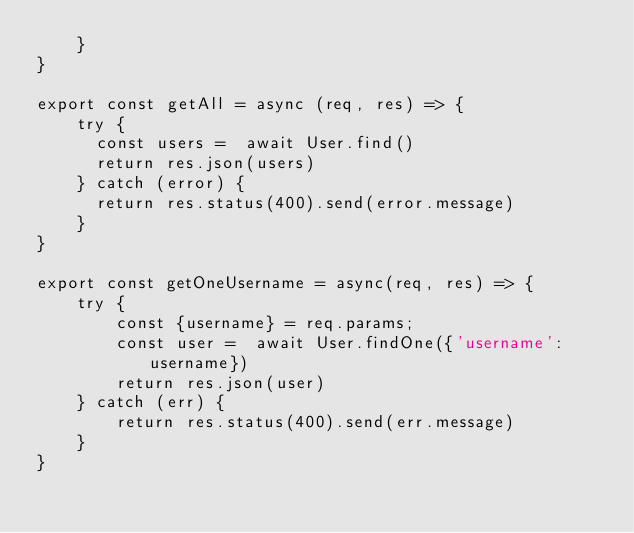<code> <loc_0><loc_0><loc_500><loc_500><_JavaScript_>    }
}

export const getAll = async (req, res) => {
    try {
      const users =  await User.find()
      return res.json(users)
    } catch (error) {
      return res.status(400).send(error.message)
    }
}

export const getOneUsername = async(req, res) => {
    try {
        const {username} = req.params;
        const user =  await User.findOne({'username': username})
        return res.json(user)
    } catch (err) {
        return res.status(400).send(err.message)
    }
}


</code> 